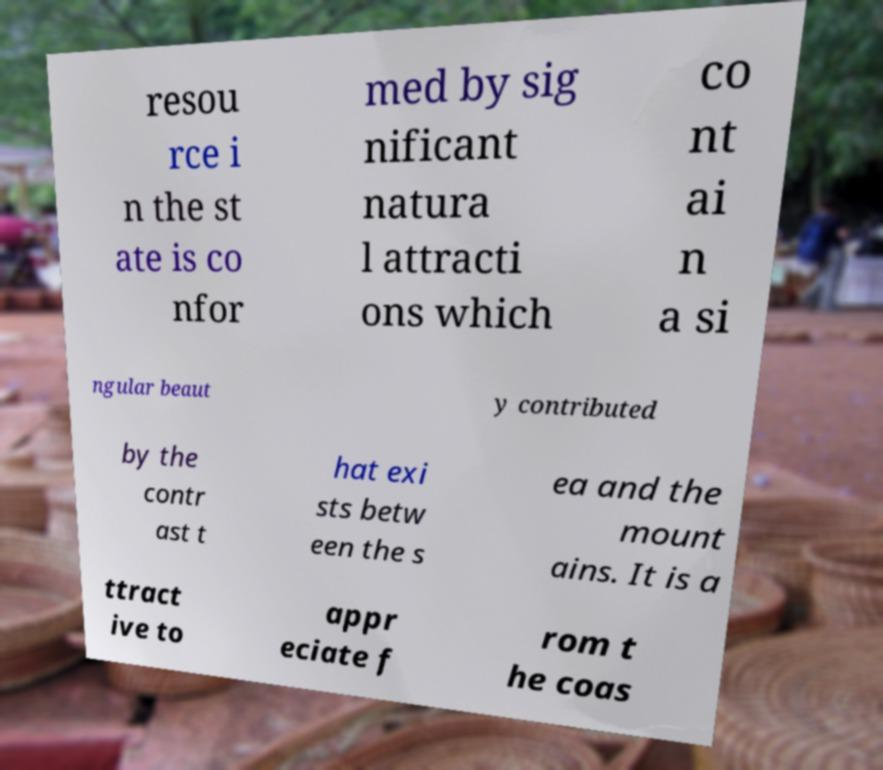For documentation purposes, I need the text within this image transcribed. Could you provide that? resou rce i n the st ate is co nfor med by sig nificant natura l attracti ons which co nt ai n a si ngular beaut y contributed by the contr ast t hat exi sts betw een the s ea and the mount ains. It is a ttract ive to appr eciate f rom t he coas 